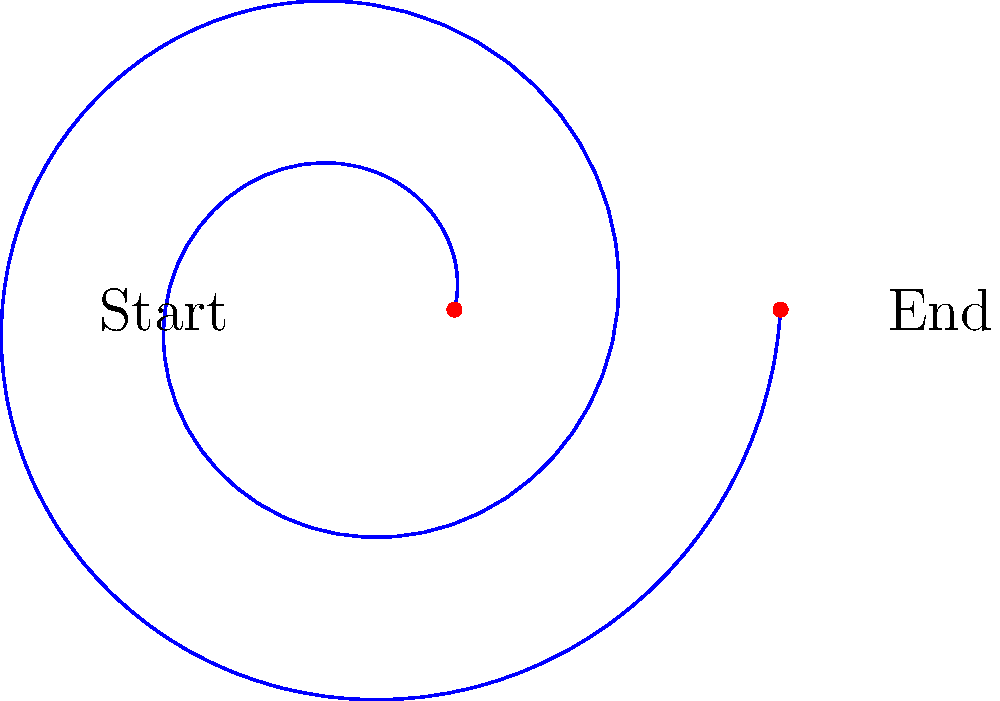A friendly dragon is flying in a spiral path. Its flight starts at a distance of 2 units from the center and spirals outward. For every full rotation, the dragon moves 0.5 units further from the center. If the dragon completes 2 full rotations, how far will it be from the center at the end of its flight? Let's break this down step-by-step:

1. The dragon starts at a distance of 2 units from the center.

2. For every full rotation (which is $2\pi$ radians), the dragon moves 0.5 units further from the center.

3. The dragon completes 2 full rotations, which means it travels through an angle of $2 \times 2\pi = 4\pi$ radians.

4. We can represent the dragon's path using the polar equation:
   $r = 2 + 0.5\theta$, where $r$ is the distance from the center and $\theta$ is the angle in radians.

5. To find the final distance, we need to calculate $r$ when $\theta = 4\pi$:
   
   $r = 2 + 0.5(4\pi)$
   $r = 2 + 2\pi$

6. Now, let's calculate this:
   $r = 2 + 2 \times 3.14159...$
   $r \approx 8.28$ units

Therefore, at the end of its flight, the dragon will be approximately 8.28 units from the center.
Answer: $2 + 2\pi$ units (approximately 8.28 units) 